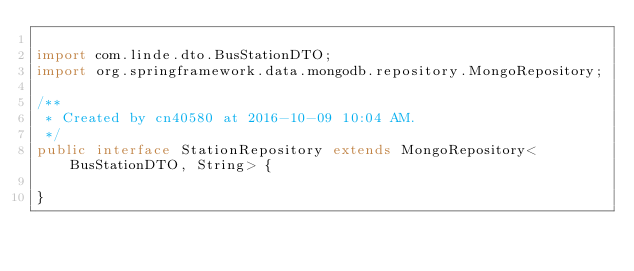<code> <loc_0><loc_0><loc_500><loc_500><_Java_>
import com.linde.dto.BusStationDTO;
import org.springframework.data.mongodb.repository.MongoRepository;

/**
 * Created by cn40580 at 2016-10-09 10:04 AM.
 */
public interface StationRepository extends MongoRepository<BusStationDTO, String> {

}
</code> 